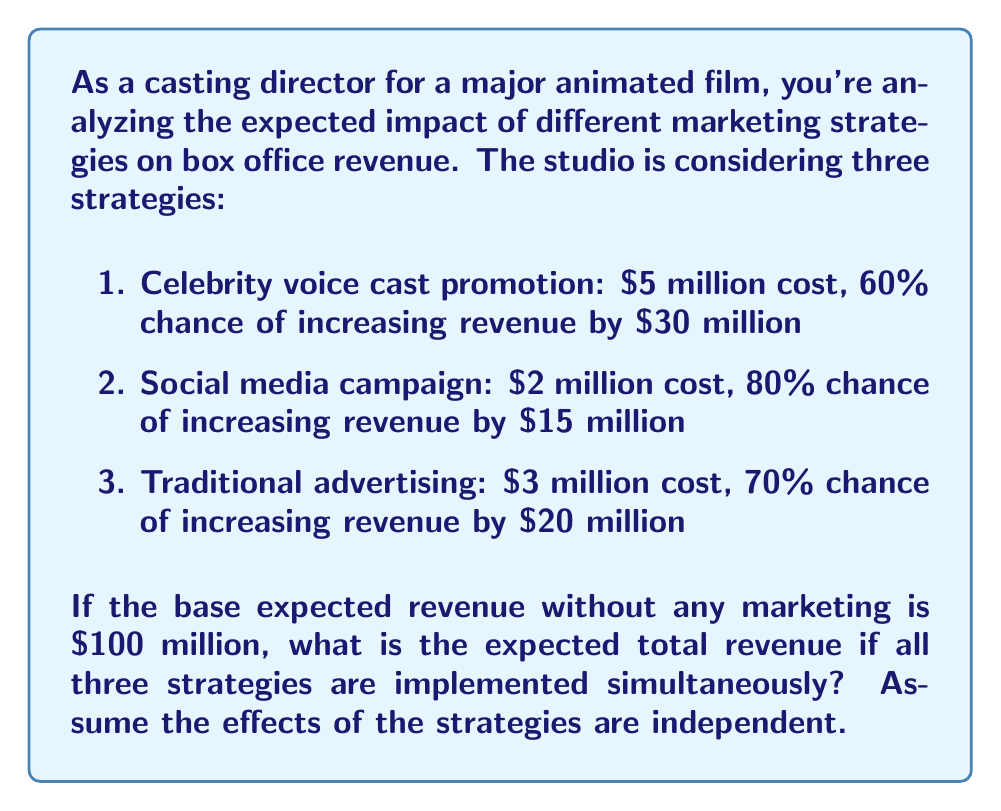Can you solve this math problem? Let's approach this step-by-step:

1) First, we need to calculate the expected value (EV) of each strategy:

   Strategy 1 (Celebrity voice cast promotion):
   $EV_1 = 0.60 \times \$30M - \$5M = \$13M$

   Strategy 2 (Social media campaign):
   $EV_2 = 0.80 \times \$15M - \$2M = \$10M$

   Strategy 3 (Traditional advertising):
   $EV_3 = 0.70 \times \$20M - \$3M = \$11M$

2) Since the effects are independent, we can sum these expected values:

   $EV_{total} = EV_1 + EV_2 + EV_3 = \$13M + \$10M + \$11M = \$34M$

3) Now, we add this to the base expected revenue:

   $Expected\ Total\ Revenue = Base\ Revenue + EV_{total}$
   $= \$100M + \$34M = \$134M$

Therefore, the expected total revenue if all three strategies are implemented is $134 million.
Answer: $134 million 